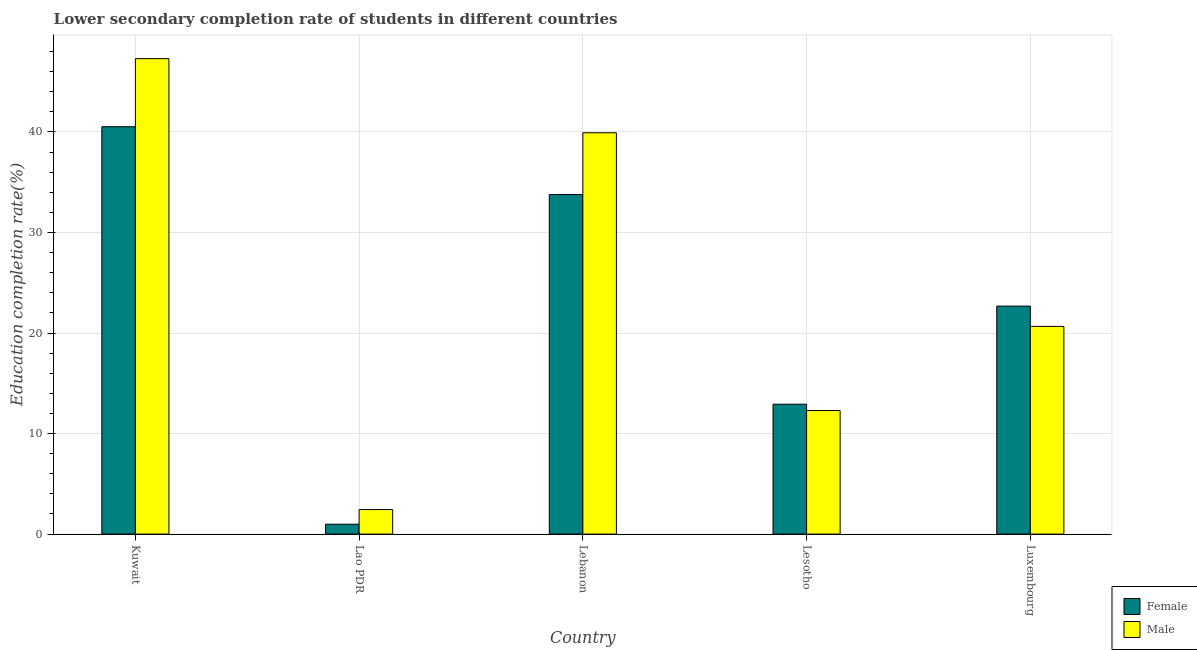How many different coloured bars are there?
Provide a succinct answer. 2. Are the number of bars on each tick of the X-axis equal?
Your answer should be compact. Yes. How many bars are there on the 4th tick from the left?
Keep it short and to the point. 2. How many bars are there on the 3rd tick from the right?
Make the answer very short. 2. What is the label of the 3rd group of bars from the left?
Provide a succinct answer. Lebanon. What is the education completion rate of female students in Lesotho?
Offer a very short reply. 12.92. Across all countries, what is the maximum education completion rate of female students?
Give a very brief answer. 40.52. Across all countries, what is the minimum education completion rate of male students?
Your response must be concise. 2.44. In which country was the education completion rate of male students maximum?
Keep it short and to the point. Kuwait. In which country was the education completion rate of female students minimum?
Offer a very short reply. Lao PDR. What is the total education completion rate of female students in the graph?
Offer a very short reply. 110.88. What is the difference between the education completion rate of female students in Kuwait and that in Lesotho?
Provide a short and direct response. 27.6. What is the difference between the education completion rate of female students in Lebanon and the education completion rate of male students in Kuwait?
Give a very brief answer. -13.52. What is the average education completion rate of male students per country?
Your response must be concise. 24.52. What is the difference between the education completion rate of female students and education completion rate of male students in Kuwait?
Your response must be concise. -6.77. In how many countries, is the education completion rate of female students greater than 22 %?
Make the answer very short. 3. What is the ratio of the education completion rate of male students in Kuwait to that in Luxembourg?
Your answer should be very brief. 2.29. Is the education completion rate of male students in Lao PDR less than that in Lebanon?
Your answer should be compact. Yes. What is the difference between the highest and the second highest education completion rate of female students?
Provide a succinct answer. 6.75. What is the difference between the highest and the lowest education completion rate of male students?
Your answer should be very brief. 44.85. In how many countries, is the education completion rate of male students greater than the average education completion rate of male students taken over all countries?
Offer a terse response. 2. What does the 2nd bar from the right in Lesotho represents?
Make the answer very short. Female. How many countries are there in the graph?
Provide a succinct answer. 5. What is the difference between two consecutive major ticks on the Y-axis?
Your response must be concise. 10. Are the values on the major ticks of Y-axis written in scientific E-notation?
Your answer should be very brief. No. Does the graph contain grids?
Offer a very short reply. Yes. How many legend labels are there?
Offer a terse response. 2. What is the title of the graph?
Keep it short and to the point. Lower secondary completion rate of students in different countries. What is the label or title of the Y-axis?
Keep it short and to the point. Education completion rate(%). What is the Education completion rate(%) of Female in Kuwait?
Ensure brevity in your answer.  40.52. What is the Education completion rate(%) in Male in Kuwait?
Make the answer very short. 47.29. What is the Education completion rate(%) of Female in Lao PDR?
Offer a terse response. 0.98. What is the Education completion rate(%) of Male in Lao PDR?
Offer a very short reply. 2.44. What is the Education completion rate(%) of Female in Lebanon?
Your answer should be compact. 33.78. What is the Education completion rate(%) of Male in Lebanon?
Offer a terse response. 39.92. What is the Education completion rate(%) in Female in Lesotho?
Ensure brevity in your answer.  12.92. What is the Education completion rate(%) in Male in Lesotho?
Provide a short and direct response. 12.29. What is the Education completion rate(%) in Female in Luxembourg?
Give a very brief answer. 22.68. What is the Education completion rate(%) of Male in Luxembourg?
Provide a succinct answer. 20.66. Across all countries, what is the maximum Education completion rate(%) of Female?
Your answer should be compact. 40.52. Across all countries, what is the maximum Education completion rate(%) of Male?
Make the answer very short. 47.29. Across all countries, what is the minimum Education completion rate(%) of Female?
Provide a short and direct response. 0.98. Across all countries, what is the minimum Education completion rate(%) in Male?
Your answer should be very brief. 2.44. What is the total Education completion rate(%) in Female in the graph?
Provide a short and direct response. 110.88. What is the total Education completion rate(%) in Male in the graph?
Give a very brief answer. 122.6. What is the difference between the Education completion rate(%) of Female in Kuwait and that in Lao PDR?
Provide a succinct answer. 39.54. What is the difference between the Education completion rate(%) in Male in Kuwait and that in Lao PDR?
Make the answer very short. 44.85. What is the difference between the Education completion rate(%) of Female in Kuwait and that in Lebanon?
Offer a terse response. 6.75. What is the difference between the Education completion rate(%) of Male in Kuwait and that in Lebanon?
Offer a terse response. 7.37. What is the difference between the Education completion rate(%) of Female in Kuwait and that in Lesotho?
Keep it short and to the point. 27.6. What is the difference between the Education completion rate(%) in Male in Kuwait and that in Lesotho?
Offer a very short reply. 35. What is the difference between the Education completion rate(%) of Female in Kuwait and that in Luxembourg?
Your response must be concise. 17.85. What is the difference between the Education completion rate(%) of Male in Kuwait and that in Luxembourg?
Your answer should be compact. 26.63. What is the difference between the Education completion rate(%) in Female in Lao PDR and that in Lebanon?
Give a very brief answer. -32.79. What is the difference between the Education completion rate(%) in Male in Lao PDR and that in Lebanon?
Give a very brief answer. -37.48. What is the difference between the Education completion rate(%) of Female in Lao PDR and that in Lesotho?
Keep it short and to the point. -11.94. What is the difference between the Education completion rate(%) of Male in Lao PDR and that in Lesotho?
Offer a very short reply. -9.85. What is the difference between the Education completion rate(%) in Female in Lao PDR and that in Luxembourg?
Offer a very short reply. -21.7. What is the difference between the Education completion rate(%) of Male in Lao PDR and that in Luxembourg?
Your answer should be compact. -18.22. What is the difference between the Education completion rate(%) in Female in Lebanon and that in Lesotho?
Provide a succinct answer. 20.85. What is the difference between the Education completion rate(%) of Male in Lebanon and that in Lesotho?
Offer a terse response. 27.63. What is the difference between the Education completion rate(%) in Female in Lebanon and that in Luxembourg?
Offer a terse response. 11.1. What is the difference between the Education completion rate(%) of Male in Lebanon and that in Luxembourg?
Keep it short and to the point. 19.26. What is the difference between the Education completion rate(%) of Female in Lesotho and that in Luxembourg?
Offer a very short reply. -9.76. What is the difference between the Education completion rate(%) in Male in Lesotho and that in Luxembourg?
Give a very brief answer. -8.37. What is the difference between the Education completion rate(%) in Female in Kuwait and the Education completion rate(%) in Male in Lao PDR?
Make the answer very short. 38.09. What is the difference between the Education completion rate(%) in Female in Kuwait and the Education completion rate(%) in Male in Lebanon?
Give a very brief answer. 0.6. What is the difference between the Education completion rate(%) of Female in Kuwait and the Education completion rate(%) of Male in Lesotho?
Your answer should be very brief. 28.23. What is the difference between the Education completion rate(%) of Female in Kuwait and the Education completion rate(%) of Male in Luxembourg?
Ensure brevity in your answer.  19.86. What is the difference between the Education completion rate(%) in Female in Lao PDR and the Education completion rate(%) in Male in Lebanon?
Provide a succinct answer. -38.94. What is the difference between the Education completion rate(%) of Female in Lao PDR and the Education completion rate(%) of Male in Lesotho?
Give a very brief answer. -11.31. What is the difference between the Education completion rate(%) of Female in Lao PDR and the Education completion rate(%) of Male in Luxembourg?
Your answer should be compact. -19.68. What is the difference between the Education completion rate(%) in Female in Lebanon and the Education completion rate(%) in Male in Lesotho?
Your response must be concise. 21.48. What is the difference between the Education completion rate(%) of Female in Lebanon and the Education completion rate(%) of Male in Luxembourg?
Offer a very short reply. 13.11. What is the difference between the Education completion rate(%) in Female in Lesotho and the Education completion rate(%) in Male in Luxembourg?
Your response must be concise. -7.74. What is the average Education completion rate(%) of Female per country?
Ensure brevity in your answer.  22.18. What is the average Education completion rate(%) of Male per country?
Provide a short and direct response. 24.52. What is the difference between the Education completion rate(%) in Female and Education completion rate(%) in Male in Kuwait?
Make the answer very short. -6.77. What is the difference between the Education completion rate(%) of Female and Education completion rate(%) of Male in Lao PDR?
Provide a short and direct response. -1.46. What is the difference between the Education completion rate(%) of Female and Education completion rate(%) of Male in Lebanon?
Offer a terse response. -6.14. What is the difference between the Education completion rate(%) of Female and Education completion rate(%) of Male in Lesotho?
Your answer should be very brief. 0.63. What is the difference between the Education completion rate(%) of Female and Education completion rate(%) of Male in Luxembourg?
Provide a succinct answer. 2.02. What is the ratio of the Education completion rate(%) in Female in Kuwait to that in Lao PDR?
Keep it short and to the point. 41.27. What is the ratio of the Education completion rate(%) of Male in Kuwait to that in Lao PDR?
Ensure brevity in your answer.  19.4. What is the ratio of the Education completion rate(%) in Female in Kuwait to that in Lebanon?
Provide a short and direct response. 1.2. What is the ratio of the Education completion rate(%) in Male in Kuwait to that in Lebanon?
Your response must be concise. 1.18. What is the ratio of the Education completion rate(%) of Female in Kuwait to that in Lesotho?
Offer a terse response. 3.14. What is the ratio of the Education completion rate(%) of Male in Kuwait to that in Lesotho?
Offer a very short reply. 3.85. What is the ratio of the Education completion rate(%) in Female in Kuwait to that in Luxembourg?
Make the answer very short. 1.79. What is the ratio of the Education completion rate(%) of Male in Kuwait to that in Luxembourg?
Make the answer very short. 2.29. What is the ratio of the Education completion rate(%) of Female in Lao PDR to that in Lebanon?
Offer a terse response. 0.03. What is the ratio of the Education completion rate(%) of Male in Lao PDR to that in Lebanon?
Your answer should be very brief. 0.06. What is the ratio of the Education completion rate(%) of Female in Lao PDR to that in Lesotho?
Your answer should be very brief. 0.08. What is the ratio of the Education completion rate(%) of Male in Lao PDR to that in Lesotho?
Your response must be concise. 0.2. What is the ratio of the Education completion rate(%) in Female in Lao PDR to that in Luxembourg?
Offer a very short reply. 0.04. What is the ratio of the Education completion rate(%) of Male in Lao PDR to that in Luxembourg?
Your answer should be very brief. 0.12. What is the ratio of the Education completion rate(%) of Female in Lebanon to that in Lesotho?
Provide a short and direct response. 2.61. What is the ratio of the Education completion rate(%) of Male in Lebanon to that in Lesotho?
Make the answer very short. 3.25. What is the ratio of the Education completion rate(%) in Female in Lebanon to that in Luxembourg?
Your answer should be compact. 1.49. What is the ratio of the Education completion rate(%) in Male in Lebanon to that in Luxembourg?
Keep it short and to the point. 1.93. What is the ratio of the Education completion rate(%) of Female in Lesotho to that in Luxembourg?
Make the answer very short. 0.57. What is the ratio of the Education completion rate(%) of Male in Lesotho to that in Luxembourg?
Your response must be concise. 0.59. What is the difference between the highest and the second highest Education completion rate(%) of Female?
Give a very brief answer. 6.75. What is the difference between the highest and the second highest Education completion rate(%) in Male?
Your answer should be very brief. 7.37. What is the difference between the highest and the lowest Education completion rate(%) in Female?
Make the answer very short. 39.54. What is the difference between the highest and the lowest Education completion rate(%) of Male?
Offer a very short reply. 44.85. 